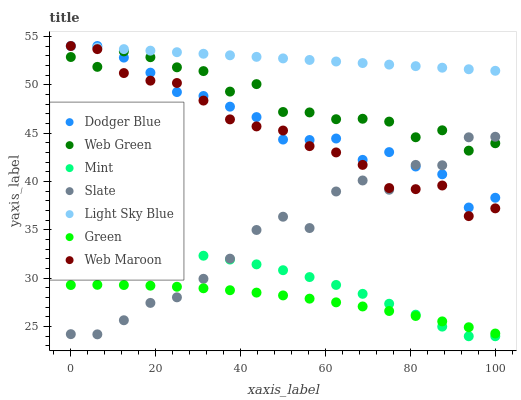Does Green have the minimum area under the curve?
Answer yes or no. Yes. Does Light Sky Blue have the maximum area under the curve?
Answer yes or no. Yes. Does Web Maroon have the minimum area under the curve?
Answer yes or no. No. Does Web Maroon have the maximum area under the curve?
Answer yes or no. No. Is Light Sky Blue the smoothest?
Answer yes or no. Yes. Is Slate the roughest?
Answer yes or no. Yes. Is Web Maroon the smoothest?
Answer yes or no. No. Is Web Maroon the roughest?
Answer yes or no. No. Does Mint have the lowest value?
Answer yes or no. Yes. Does Web Maroon have the lowest value?
Answer yes or no. No. Does Dodger Blue have the highest value?
Answer yes or no. Yes. Does Web Green have the highest value?
Answer yes or no. No. Is Web Green less than Light Sky Blue?
Answer yes or no. Yes. Is Web Maroon greater than Mint?
Answer yes or no. Yes. Does Light Sky Blue intersect Dodger Blue?
Answer yes or no. Yes. Is Light Sky Blue less than Dodger Blue?
Answer yes or no. No. Is Light Sky Blue greater than Dodger Blue?
Answer yes or no. No. Does Web Green intersect Light Sky Blue?
Answer yes or no. No. 